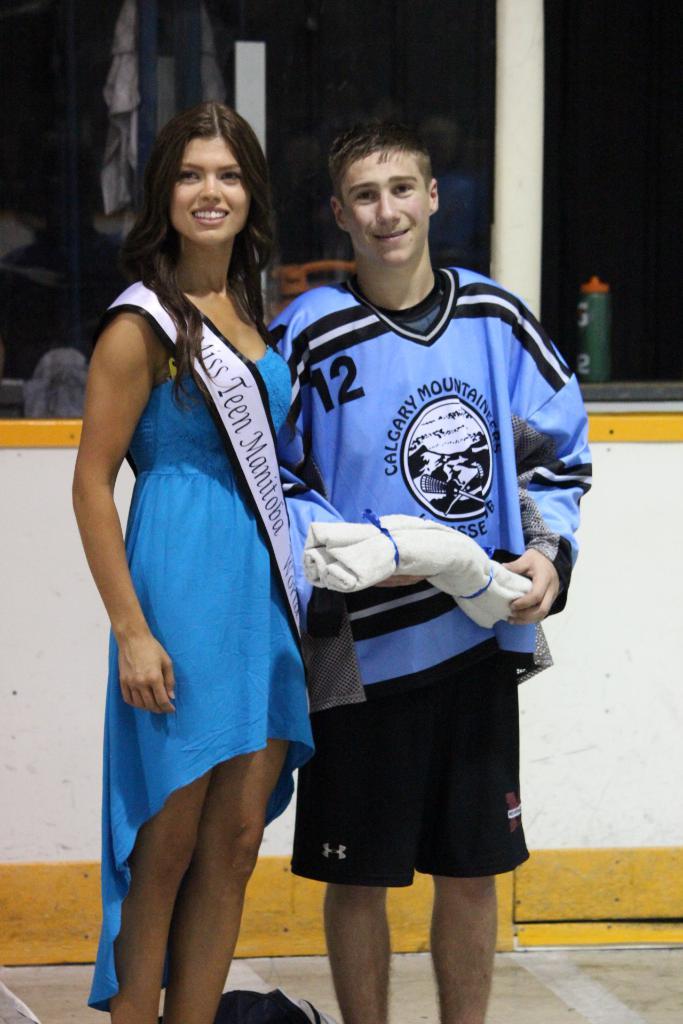What number is on the players jersey?
Provide a short and direct response. 12. What is the word after "teen" on the sash?
Give a very brief answer. Manitoba. 